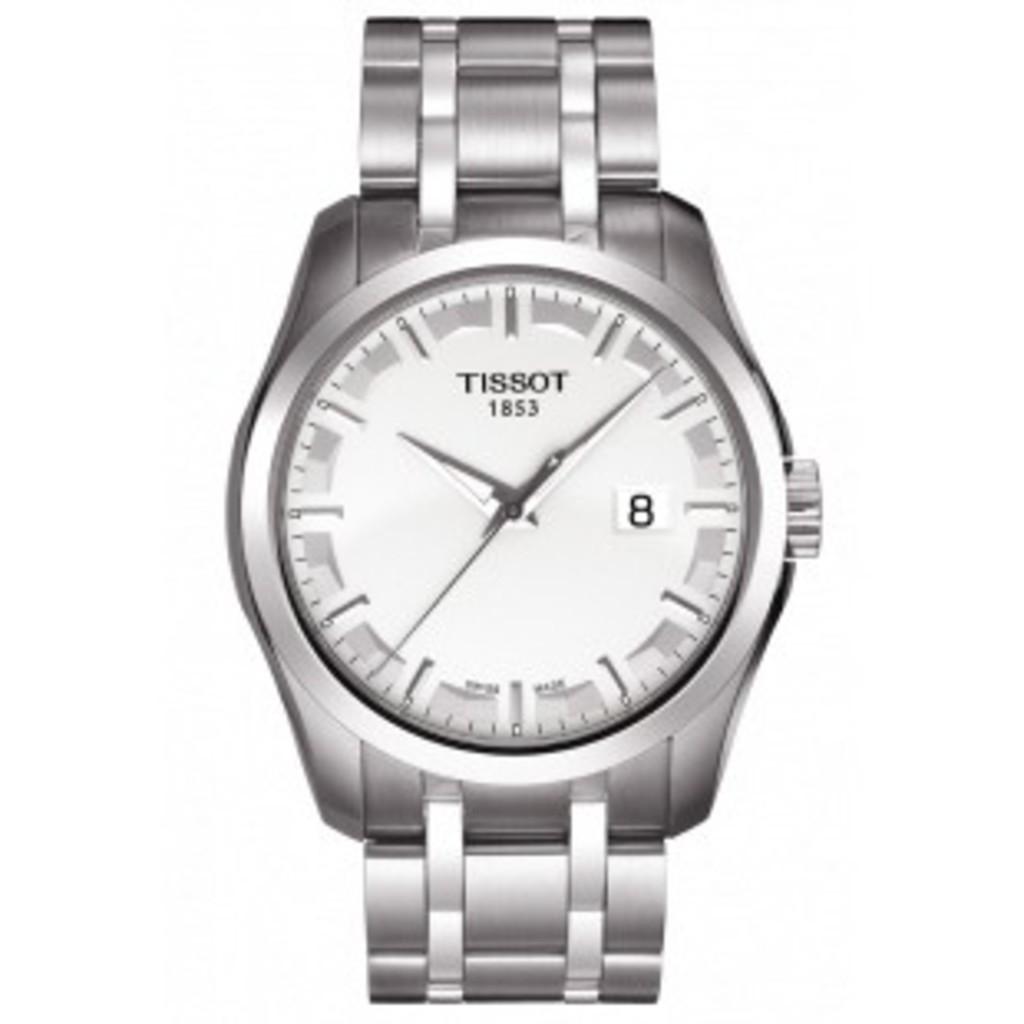What brand of watch?
Your answer should be compact. Tissot. What is the year mentioned under the brand name?
Give a very brief answer. 1853. 